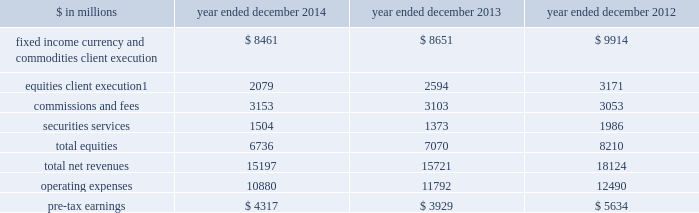Management 2019s discussion and analysis institutional client services our institutional client services segment is comprised of : fixed income , currency and commodities client execution .
Includes client execution activities related to making markets in interest rate products , credit products , mortgages , currencies and commodities .
2030 interest rate products .
Government bonds , money market instruments such as commercial paper , treasury bills , repurchase agreements and other highly liquid securities and instruments , as well as interest rate swaps , options and other derivatives .
2030 credit products .
Investment-grade corporate securities , high-yield securities , credit derivatives , bank and bridge loans , municipal securities , emerging market and distressed debt , and trade claims .
2030 mortgages .
Commercial mortgage-related securities , loans and derivatives , residential mortgage-related securities , loans and derivatives ( including u.s .
Government agency-issued collateralized mortgage obligations , other prime , subprime and alt-a securities and loans ) , and other asset-backed securities , loans and derivatives .
2030 currencies .
Most currencies , including growth-market currencies .
2030 commodities .
Crude oil and petroleum products , natural gas , base , precious and other metals , electricity , coal , agricultural and other commodity products .
Equities .
Includes client execution activities related to making markets in equity products and commissions and fees from executing and clearing institutional client transactions on major stock , options and futures exchanges worldwide , as well as otc transactions .
Equities also includes our securities services business , which provides financing , securities lending and other prime brokerage services to institutional clients , including hedge funds , mutual funds , pension funds and foundations , and generates revenues primarily in the form of interest rate spreads or fees .
The table below presents the operating results of our institutional client services segment. .
Net revenues related to the americas reinsurance business were $ 317 million for 2013 and $ 1.08 billion for 2012 .
In april 2013 , we completed the sale of a majority stake in our americas reinsurance business and no longer consolidate this business .
42 goldman sachs 2014 annual report .
What was the percentage change in pre-tax earnings for the institutional client services segment between 2013 and 2014? 
Computations: ((4317 - 3929) / 3929)
Answer: 0.09875. 